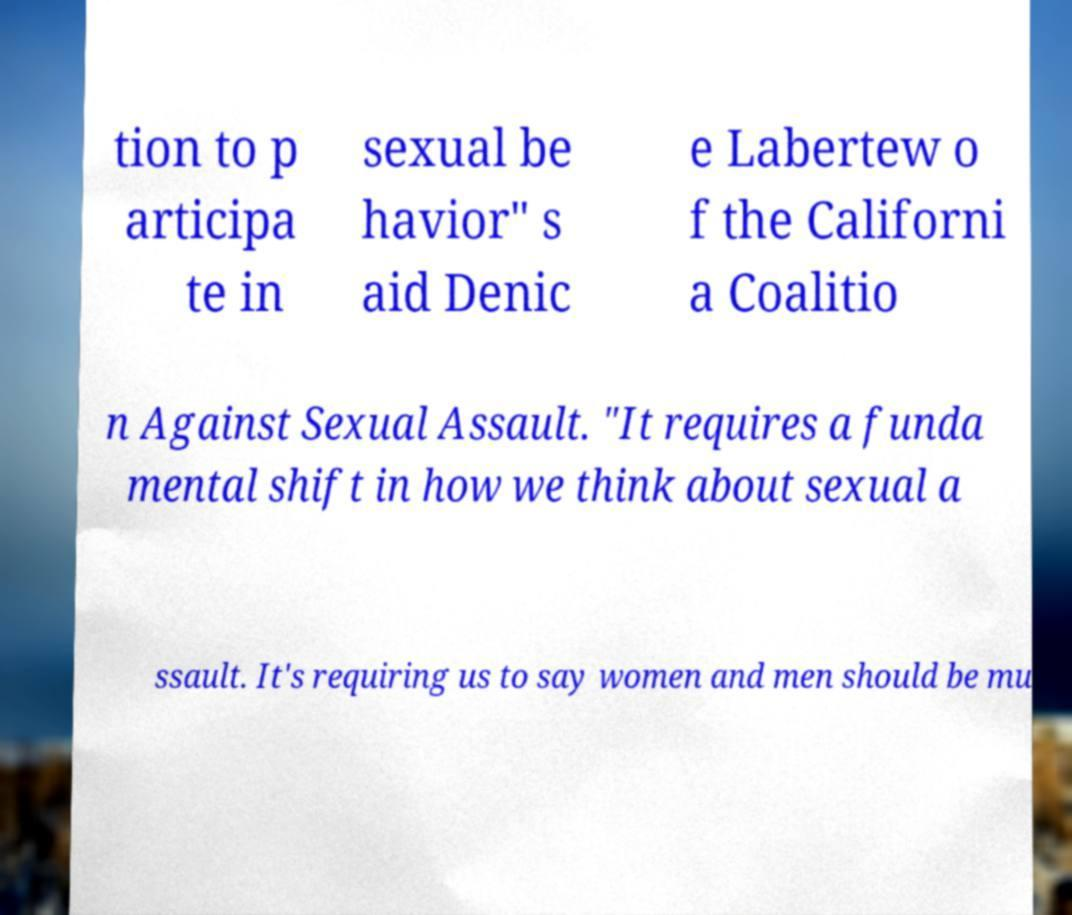Can you accurately transcribe the text from the provided image for me? tion to p articipa te in sexual be havior" s aid Denic e Labertew o f the Californi a Coalitio n Against Sexual Assault. "It requires a funda mental shift in how we think about sexual a ssault. It's requiring us to say women and men should be mu 